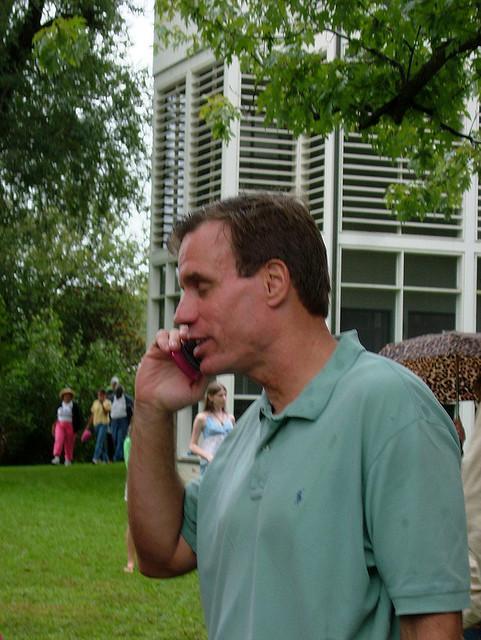How many people are in the picture?
Give a very brief answer. 2. How many oranges are these?
Give a very brief answer. 0. 